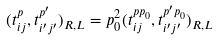<formula> <loc_0><loc_0><loc_500><loc_500>( t _ { i j } ^ { p } , t _ { i ^ { \prime } j ^ { \prime } } ^ { p ^ { \prime } } ) _ { R , L } = p _ { 0 } ^ { 2 } ( t _ { i j } ^ { p p _ { 0 } } , t _ { i ^ { \prime } j ^ { \prime } } ^ { p ^ { \prime } p _ { 0 } } ) _ { R , L }</formula> 